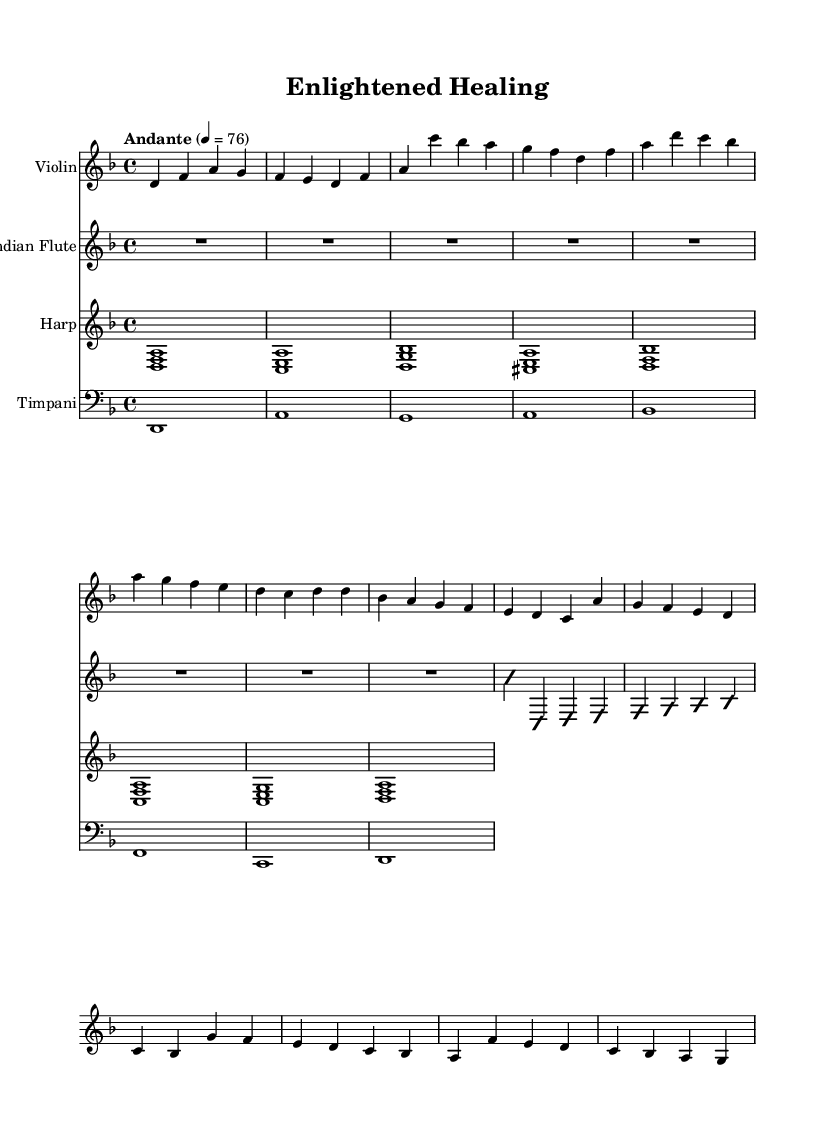What is the key signature of this music? The key signature is indicated by the two flats in the signature area, which corresponds to B flat and E flat, typical for D minor.
Answer: D minor What is the time signature of this music? The time signature is located at the beginning of the score and shows "4/4", indicating there are four beats per measure.
Answer: 4/4 What is the tempo marking given in this piece? The tempo marking is found above the staff, labeled as "Andante" with a metronome indication of 76 beats per minute, meaning a moderate walking pace.
Answer: Andante, 76 How many measures are in the main theme section? By counting the measures in the mainTheme section of the violin staff, there are four distinct measures presented in that theme.
Answer: 4 Which instrument plays the defined main theme first? The mainTheme is notated in the violin staff, indicating that the violin is the first instrument to play this section.
Answer: Violin What types of musical techniques are indicated in the flute section? The flute section indicates an "improvisationOn" followed by a series of ascending notes, which suggests a free-form addendum after establishing the melodic structure.
Answer: Improvisation What instruments are combined in the score? Looking at the score, four instruments are visible: Violin, Indian Flute, Harp, and Timpani, showcasing a blend of strings, woodwinds, and percussion features.
Answer: Violin, Indian Flute, Harp, Timpani 